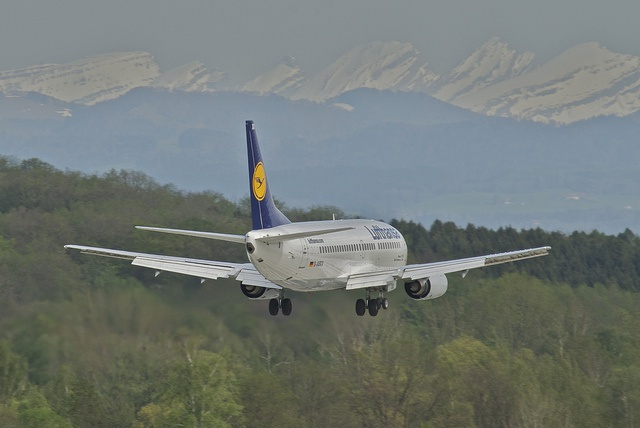Describe the objects in this image and their specific colors. I can see a airplane in gray, darkgray, lightgray, and black tones in this image. 